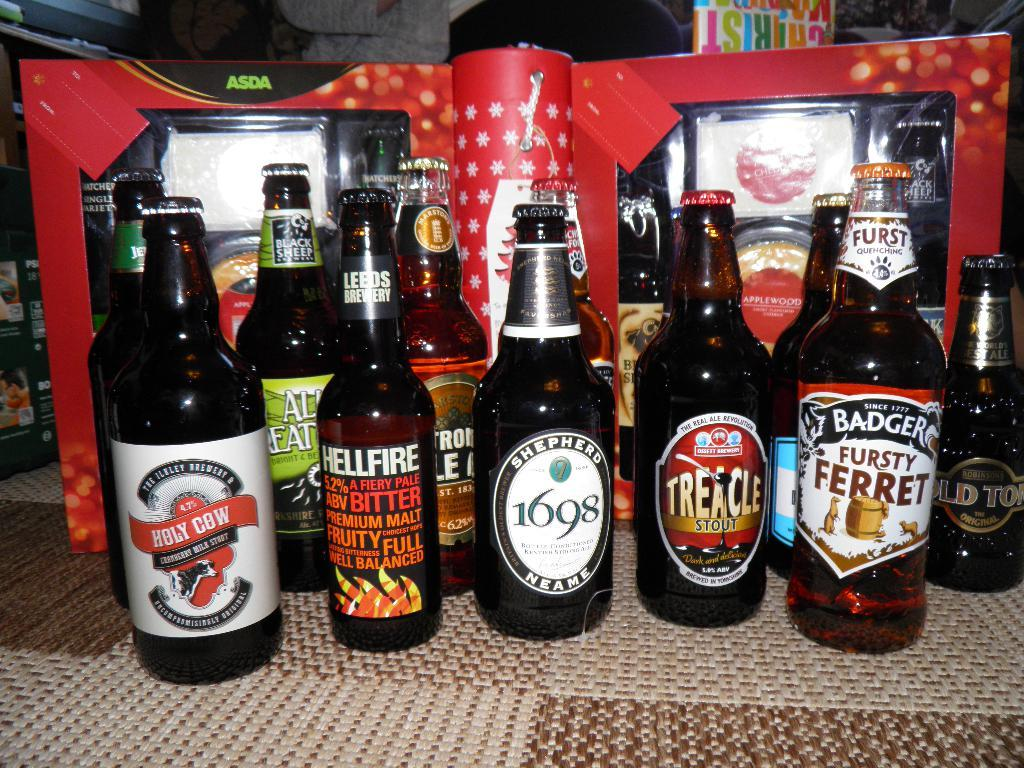Provide a one-sentence caption for the provided image. Different bottles of beer are arranged on carpet tiles, including one called Holy Cow. 